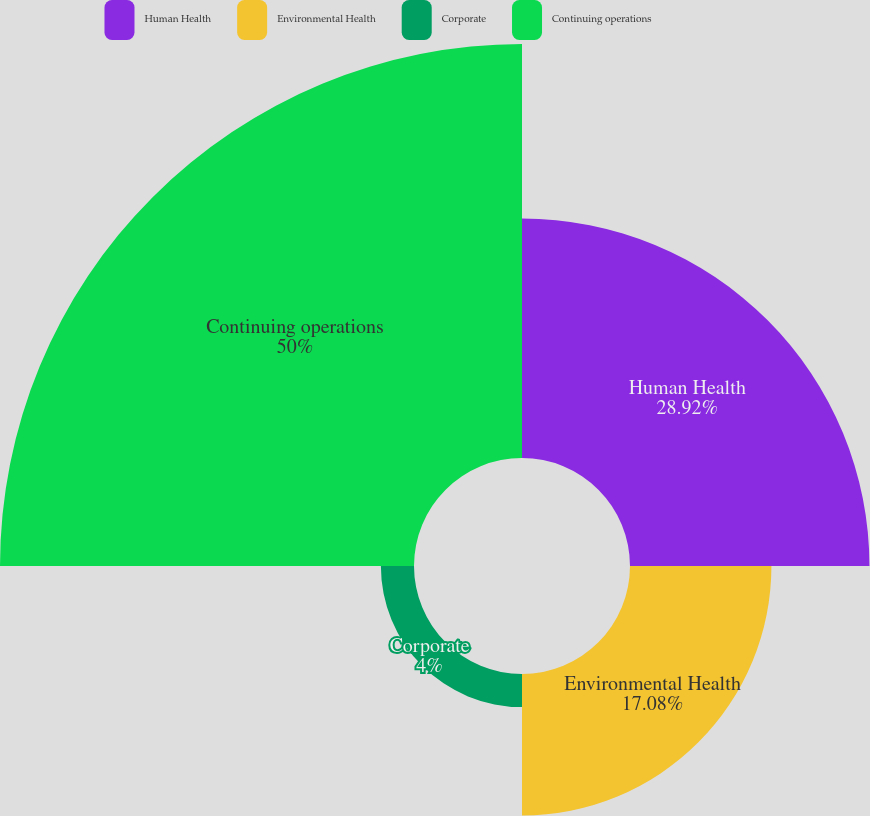Convert chart to OTSL. <chart><loc_0><loc_0><loc_500><loc_500><pie_chart><fcel>Human Health<fcel>Environmental Health<fcel>Corporate<fcel>Continuing operations<nl><fcel>28.92%<fcel>17.08%<fcel>4.0%<fcel>50.0%<nl></chart> 